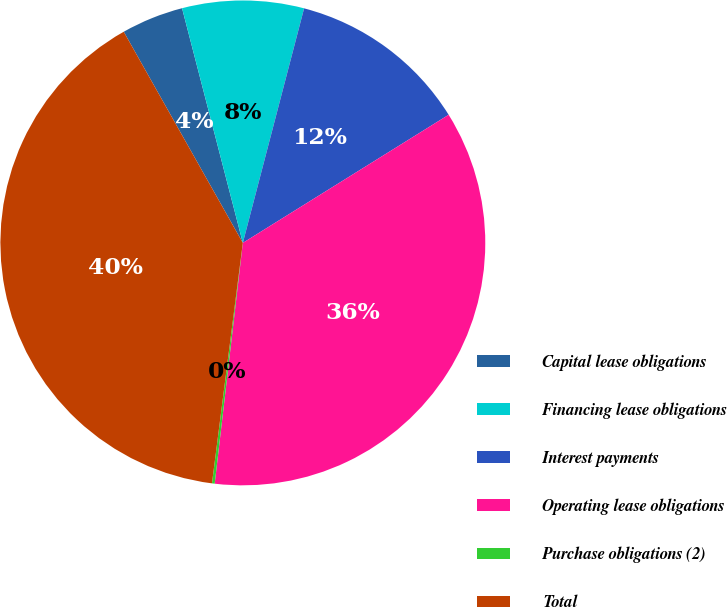<chart> <loc_0><loc_0><loc_500><loc_500><pie_chart><fcel>Capital lease obligations<fcel>Financing lease obligations<fcel>Interest payments<fcel>Operating lease obligations<fcel>Purchase obligations (2)<fcel>Total<nl><fcel>4.14%<fcel>8.1%<fcel>12.07%<fcel>35.71%<fcel>0.18%<fcel>39.79%<nl></chart> 